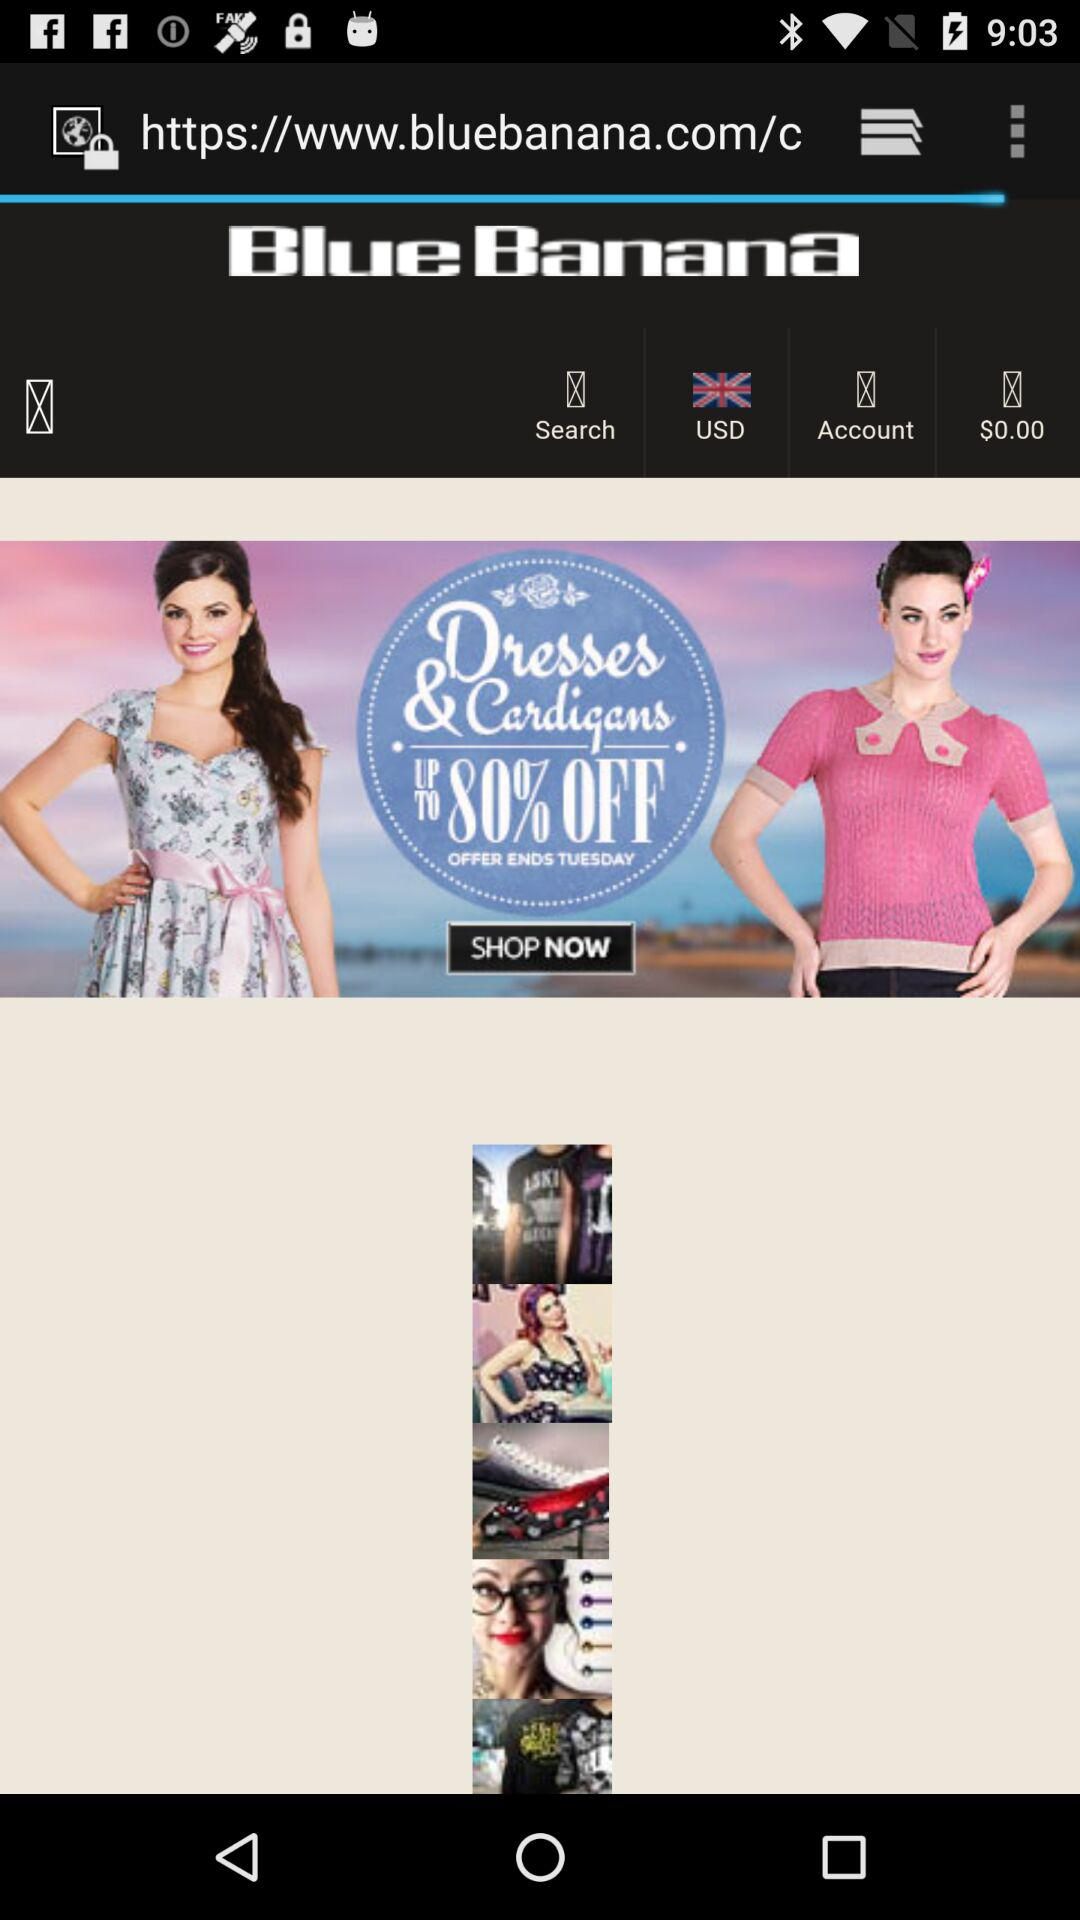How many dollars are there? There are 0 dollars. 